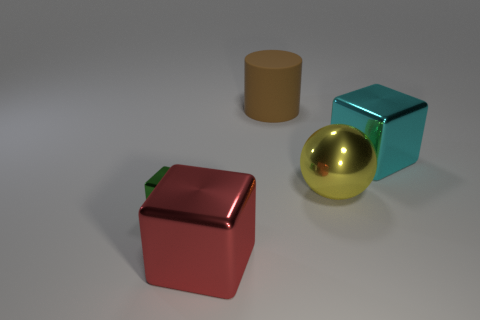Subtract 1 blocks. How many blocks are left? 2 Add 1 small purple shiny things. How many objects exist? 6 Subtract all balls. How many objects are left? 4 Add 5 tiny purple shiny blocks. How many tiny purple shiny blocks exist? 5 Subtract 0 yellow cubes. How many objects are left? 5 Subtract all large matte cylinders. Subtract all big yellow metallic balls. How many objects are left? 3 Add 4 large spheres. How many large spheres are left? 5 